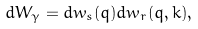Convert formula to latex. <formula><loc_0><loc_0><loc_500><loc_500>d W _ { \gamma } = d w _ { s } ( { q } ) d w _ { r } ( { q } , { k } ) ,</formula> 